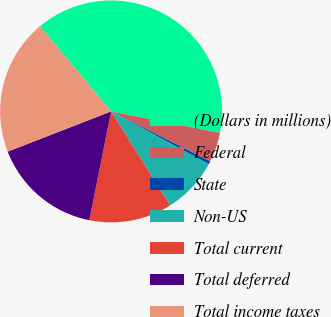<chart> <loc_0><loc_0><loc_500><loc_500><pie_chart><fcel>(Dollars in millions)<fcel>Federal<fcel>State<fcel>Non-US<fcel>Total current<fcel>Total deferred<fcel>Total income taxes<nl><fcel>39.19%<fcel>4.32%<fcel>0.45%<fcel>8.2%<fcel>12.07%<fcel>15.95%<fcel>19.82%<nl></chart> 